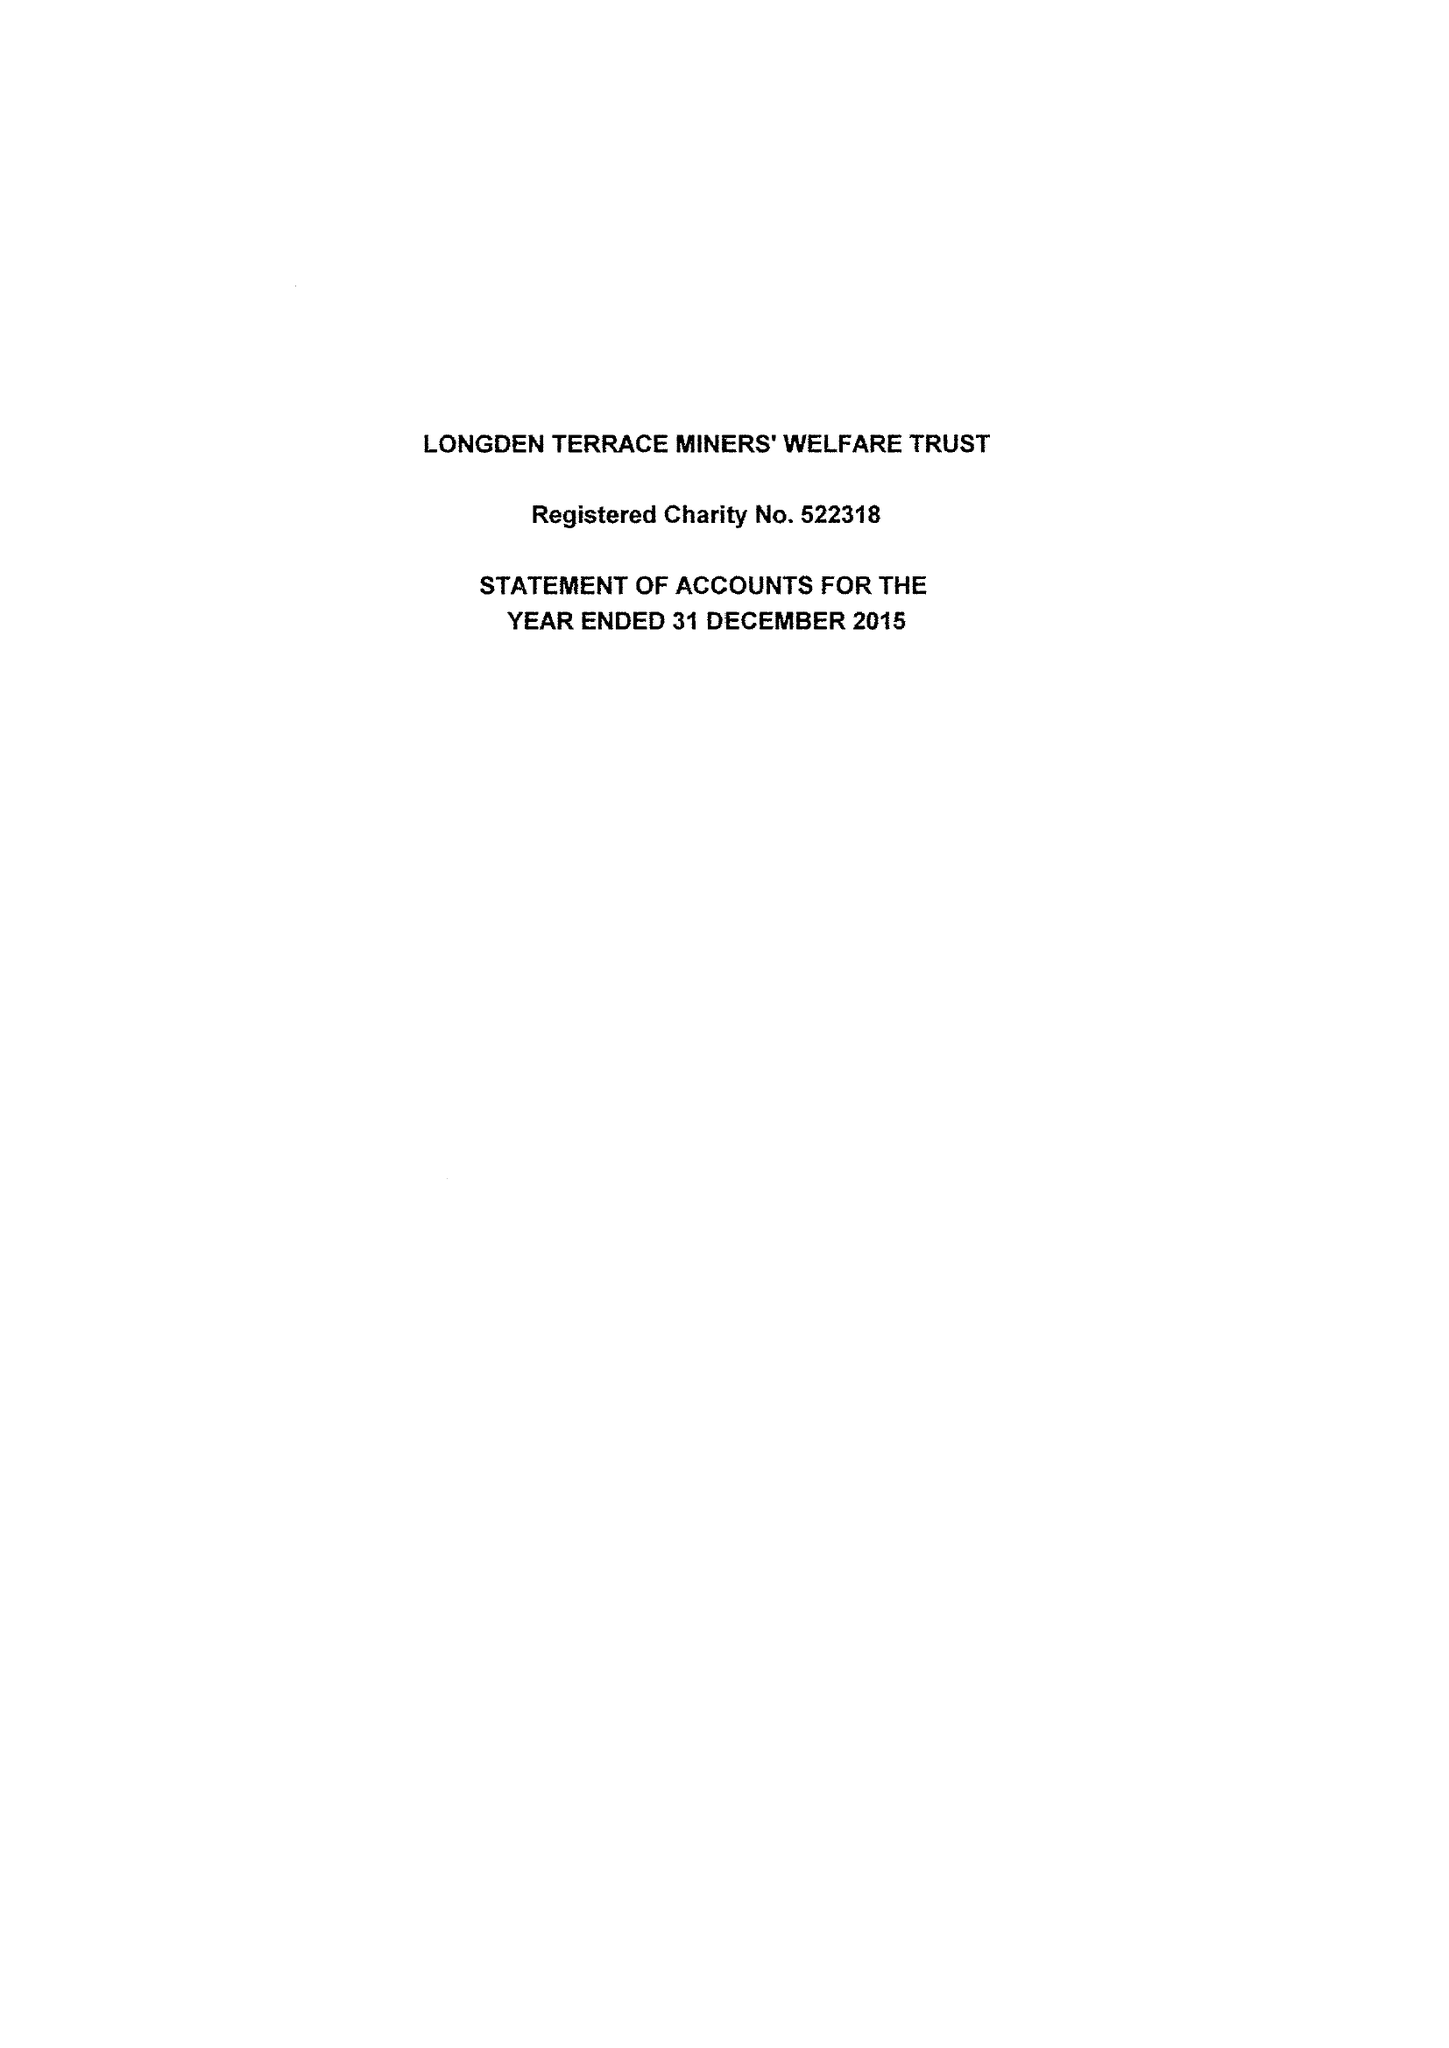What is the value for the address__post_town?
Answer the question using a single word or phrase. MANSFIELD 